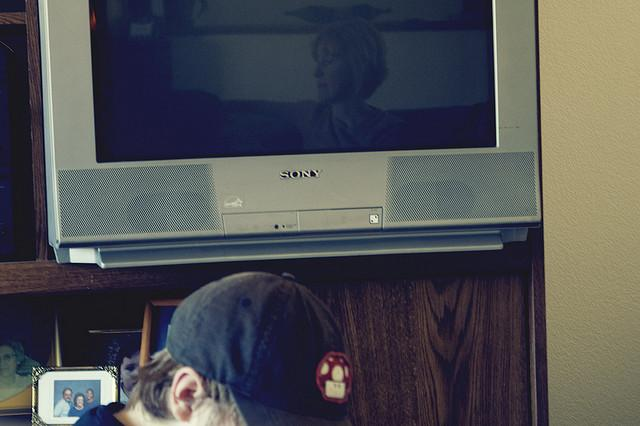When did the TV company start using this name? 1958 